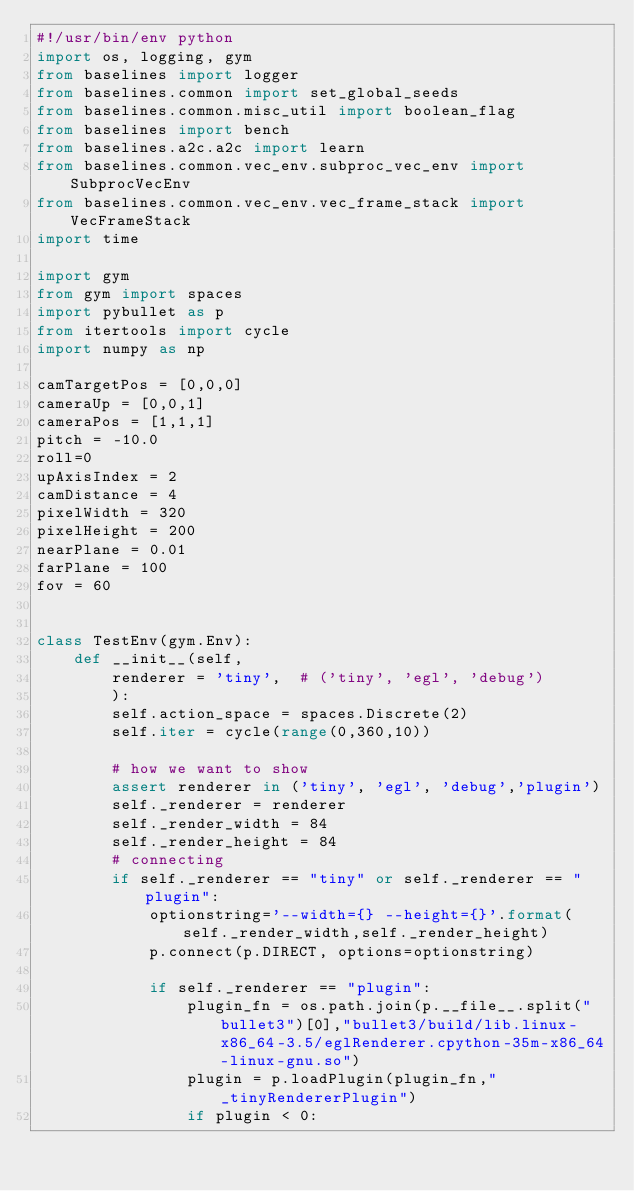Convert code to text. <code><loc_0><loc_0><loc_500><loc_500><_Python_>#!/usr/bin/env python
import os, logging, gym
from baselines import logger
from baselines.common import set_global_seeds
from baselines.common.misc_util import boolean_flag
from baselines import bench
from baselines.a2c.a2c import learn
from baselines.common.vec_env.subproc_vec_env import SubprocVecEnv
from baselines.common.vec_env.vec_frame_stack import VecFrameStack
import time

import gym
from gym import spaces
import pybullet as p
from itertools import cycle
import numpy as np

camTargetPos = [0,0,0]
cameraUp = [0,0,1]
cameraPos = [1,1,1]
pitch = -10.0
roll=0
upAxisIndex = 2
camDistance = 4
pixelWidth = 320
pixelHeight = 200
nearPlane = 0.01
farPlane = 100
fov = 60


class TestEnv(gym.Env):
    def __init__(self,
        renderer = 'tiny',  # ('tiny', 'egl', 'debug')
        ):
        self.action_space = spaces.Discrete(2)
        self.iter = cycle(range(0,360,10))

        # how we want to show
        assert renderer in ('tiny', 'egl', 'debug','plugin')
        self._renderer = renderer
        self._render_width = 84
        self._render_height = 84
        # connecting
        if self._renderer == "tiny" or self._renderer == "plugin":
            optionstring='--width={} --height={}'.format(self._render_width,self._render_height)
            p.connect(p.DIRECT, options=optionstring)

            if self._renderer == "plugin":
                plugin_fn = os.path.join(p.__file__.split("bullet3")[0],"bullet3/build/lib.linux-x86_64-3.5/eglRenderer.cpython-35m-x86_64-linux-gnu.so")
                plugin = p.loadPlugin(plugin_fn,"_tinyRendererPlugin")
                if plugin < 0:</code> 